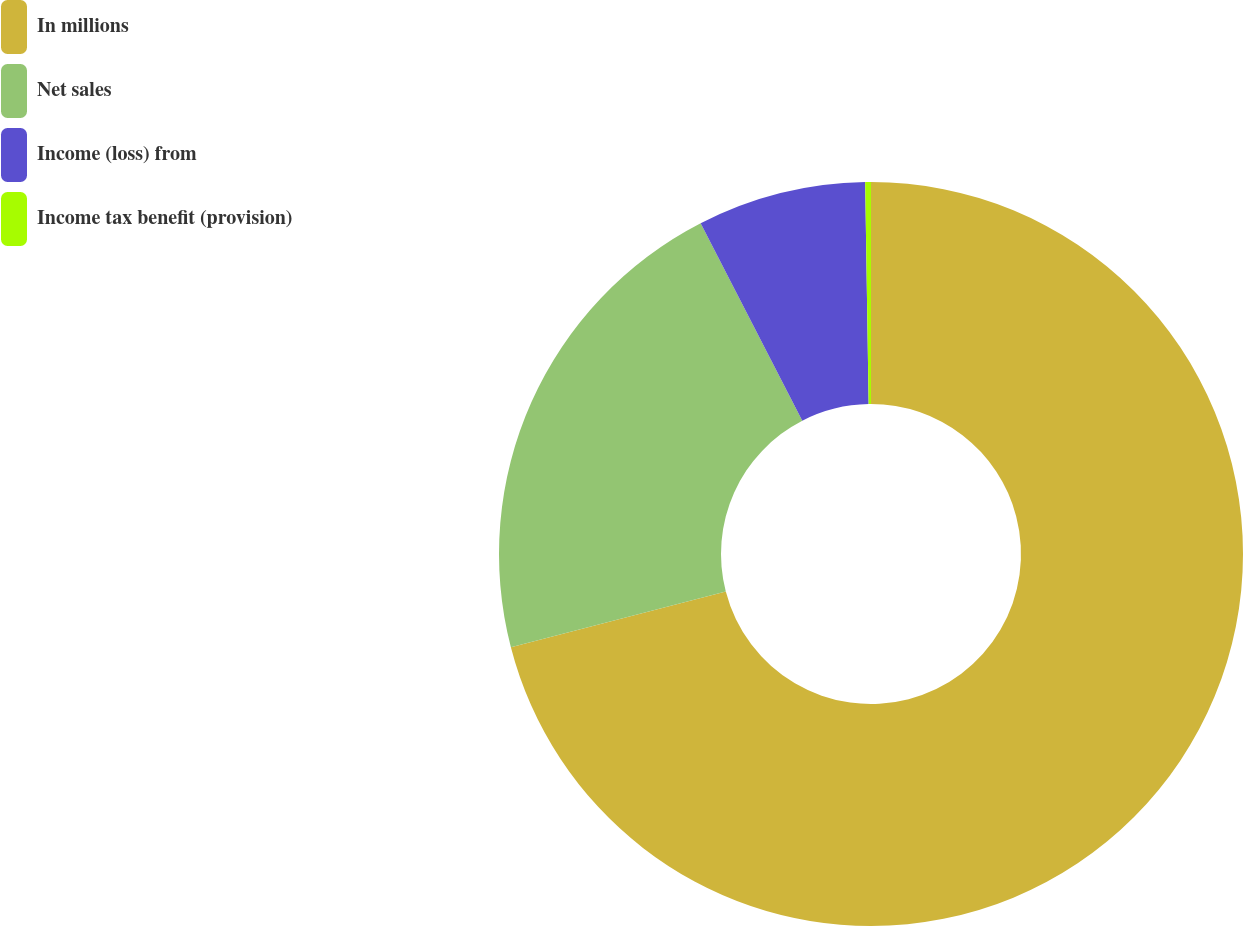<chart> <loc_0><loc_0><loc_500><loc_500><pie_chart><fcel>In millions<fcel>Net sales<fcel>Income (loss) from<fcel>Income tax benefit (provision)<nl><fcel>70.96%<fcel>21.46%<fcel>7.32%<fcel>0.25%<nl></chart> 